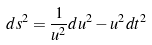<formula> <loc_0><loc_0><loc_500><loc_500>d s ^ { 2 } = \frac { 1 } { u ^ { 2 } } d u ^ { 2 } - u ^ { 2 } d t ^ { 2 }</formula> 